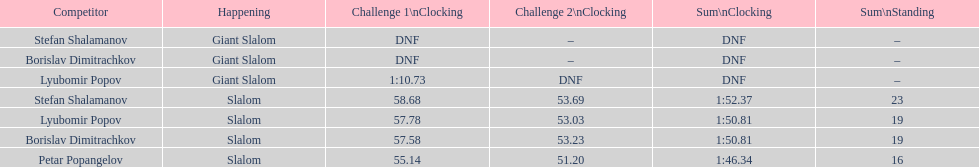How long did it take for lyubomir popov to finish the giant slalom in race 1? 1:10.73. 